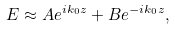Convert formula to latex. <formula><loc_0><loc_0><loc_500><loc_500>E \approx A e ^ { i k _ { 0 } z } + B e ^ { - i k _ { 0 } z } ,</formula> 